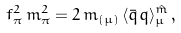<formula> <loc_0><loc_0><loc_500><loc_500>f _ { \pi } ^ { 2 } \, m _ { \pi } ^ { 2 } = 2 \, m _ { ( \mu ) } \, \langle \bar { q } q \rangle _ { \mu } ^ { \hat { m } } \, ,</formula> 